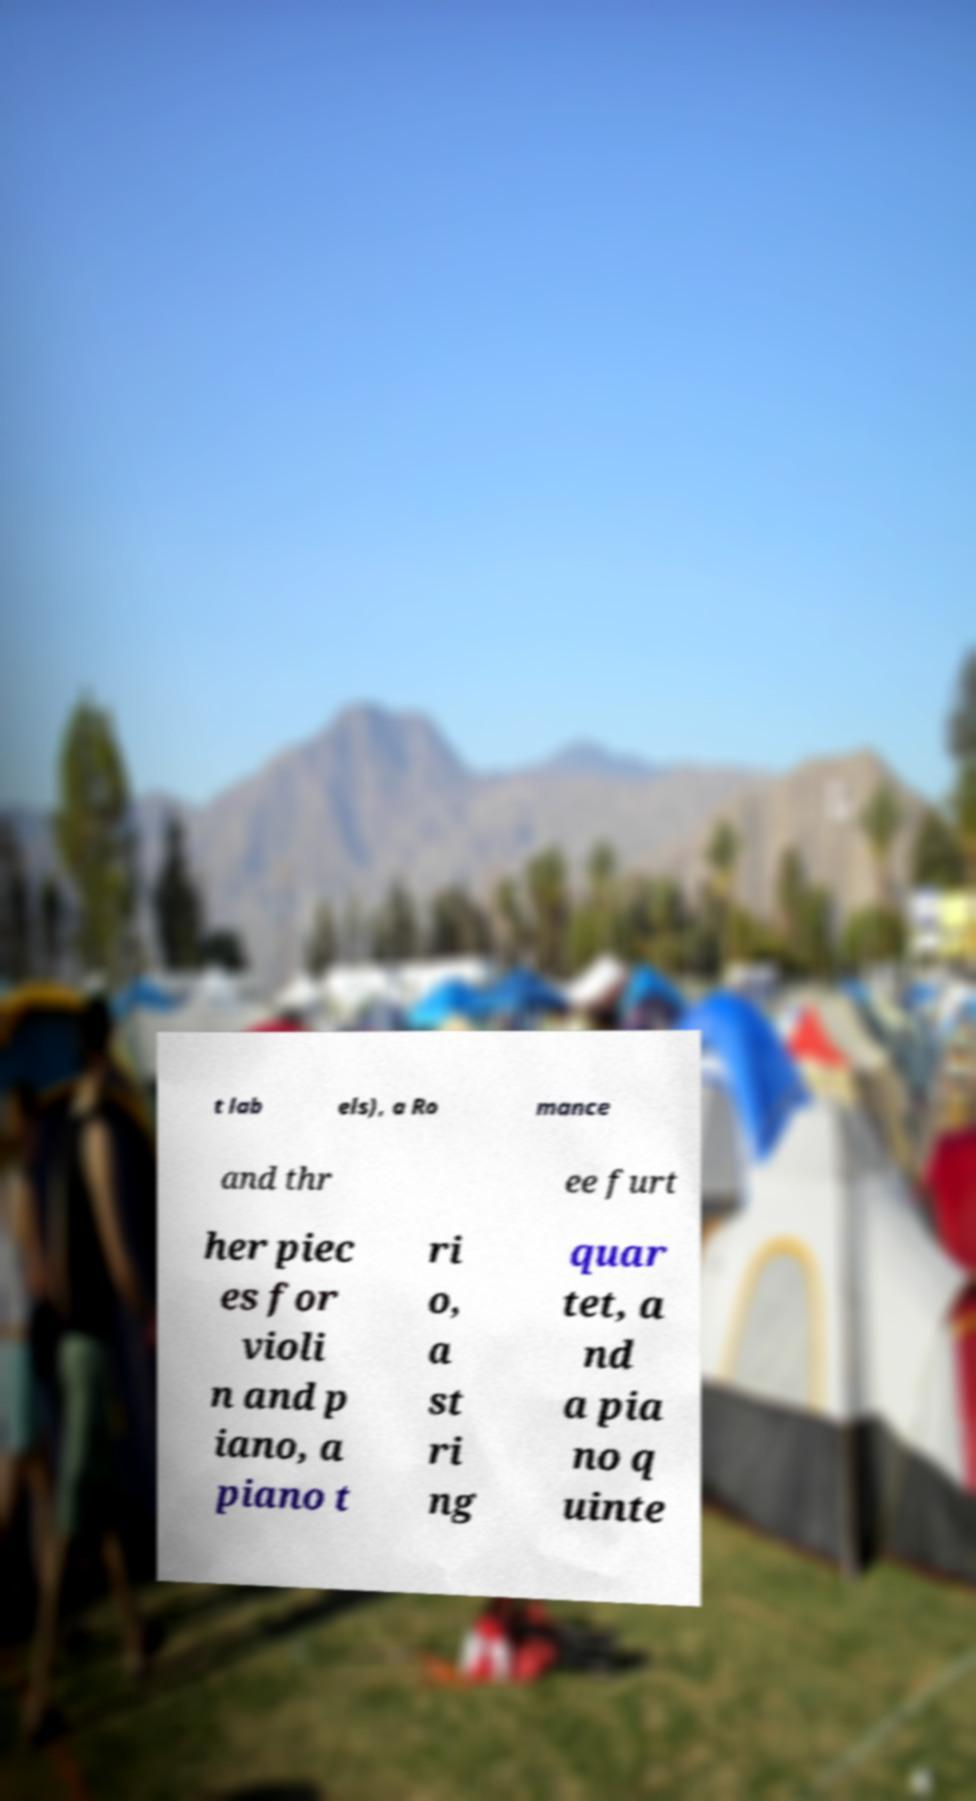There's text embedded in this image that I need extracted. Can you transcribe it verbatim? t lab els), a Ro mance and thr ee furt her piec es for violi n and p iano, a piano t ri o, a st ri ng quar tet, a nd a pia no q uinte 